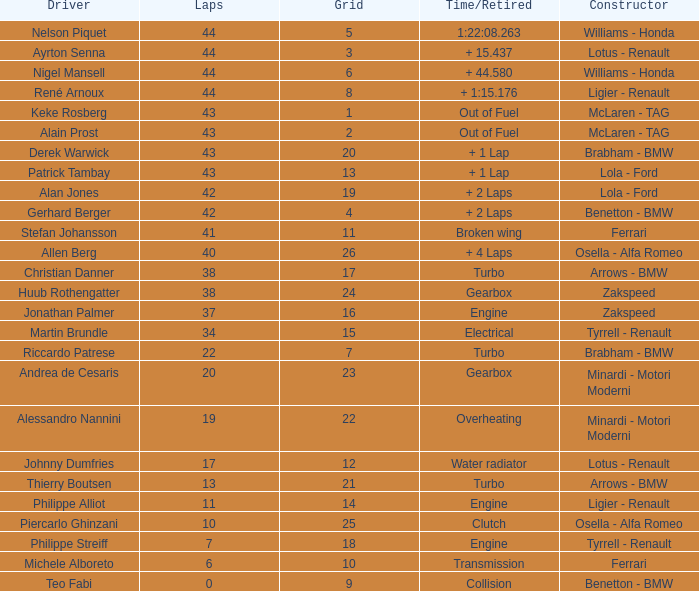Tell me the time/retired for Laps of 42 and Grids of 4 + 2 Laps. 